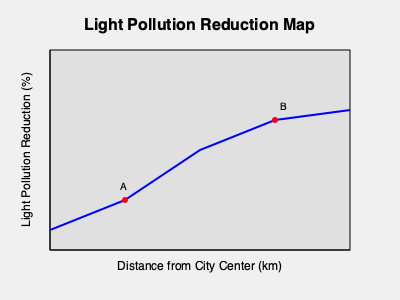The graph shows the light pollution reduction achieved after implementing solar street lighting in a city. If point A represents a 20% reduction at 5 km from the city center, and point B represents a 52% reduction at 15 km from the city center, what is the average rate of increase in light pollution reduction per kilometer between these two points? To solve this problem, we need to follow these steps:

1. Identify the change in light pollution reduction:
   - At point A (5 km): 20% reduction
   - At point B (15 km): 52% reduction
   - Change in reduction = 52% - 20% = 32%

2. Determine the distance between points A and B:
   - Distance = 15 km - 5 km = 10 km

3. Calculate the average rate of increase in light pollution reduction:
   - Rate = Change in reduction / Distance
   - Rate = 32% / 10 km

4. Simplify the rate:
   - Rate = 3.2% per km

Therefore, the average rate of increase in light pollution reduction between points A and B is 3.2% per kilometer.
Answer: 3.2% per km 